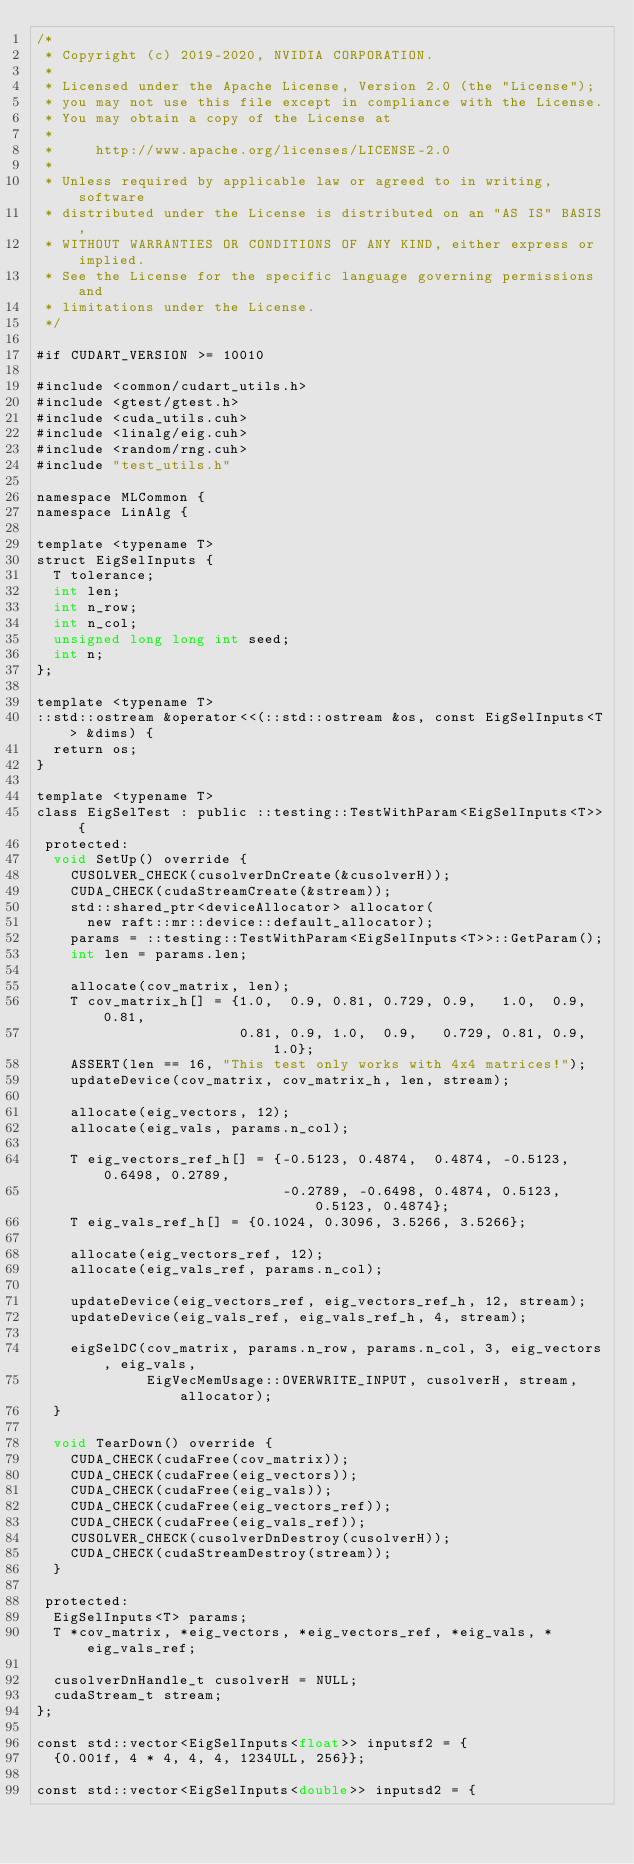<code> <loc_0><loc_0><loc_500><loc_500><_Cuda_>/*
 * Copyright (c) 2019-2020, NVIDIA CORPORATION.
 *
 * Licensed under the Apache License, Version 2.0 (the "License");
 * you may not use this file except in compliance with the License.
 * You may obtain a copy of the License at
 *
 *     http://www.apache.org/licenses/LICENSE-2.0
 *
 * Unless required by applicable law or agreed to in writing, software
 * distributed under the License is distributed on an "AS IS" BASIS,
 * WITHOUT WARRANTIES OR CONDITIONS OF ANY KIND, either express or implied.
 * See the License for the specific language governing permissions and
 * limitations under the License.
 */

#if CUDART_VERSION >= 10010

#include <common/cudart_utils.h>
#include <gtest/gtest.h>
#include <cuda_utils.cuh>
#include <linalg/eig.cuh>
#include <random/rng.cuh>
#include "test_utils.h"

namespace MLCommon {
namespace LinAlg {

template <typename T>
struct EigSelInputs {
  T tolerance;
  int len;
  int n_row;
  int n_col;
  unsigned long long int seed;
  int n;
};

template <typename T>
::std::ostream &operator<<(::std::ostream &os, const EigSelInputs<T> &dims) {
  return os;
}

template <typename T>
class EigSelTest : public ::testing::TestWithParam<EigSelInputs<T>> {
 protected:
  void SetUp() override {
    CUSOLVER_CHECK(cusolverDnCreate(&cusolverH));
    CUDA_CHECK(cudaStreamCreate(&stream));
    std::shared_ptr<deviceAllocator> allocator(
      new raft::mr::device::default_allocator);
    params = ::testing::TestWithParam<EigSelInputs<T>>::GetParam();
    int len = params.len;

    allocate(cov_matrix, len);
    T cov_matrix_h[] = {1.0,  0.9, 0.81, 0.729, 0.9,   1.0,  0.9, 0.81,
                        0.81, 0.9, 1.0,  0.9,   0.729, 0.81, 0.9, 1.0};
    ASSERT(len == 16, "This test only works with 4x4 matrices!");
    updateDevice(cov_matrix, cov_matrix_h, len, stream);

    allocate(eig_vectors, 12);
    allocate(eig_vals, params.n_col);

    T eig_vectors_ref_h[] = {-0.5123, 0.4874,  0.4874, -0.5123, 0.6498, 0.2789,
                             -0.2789, -0.6498, 0.4874, 0.5123,  0.5123, 0.4874};
    T eig_vals_ref_h[] = {0.1024, 0.3096, 3.5266, 3.5266};

    allocate(eig_vectors_ref, 12);
    allocate(eig_vals_ref, params.n_col);

    updateDevice(eig_vectors_ref, eig_vectors_ref_h, 12, stream);
    updateDevice(eig_vals_ref, eig_vals_ref_h, 4, stream);

    eigSelDC(cov_matrix, params.n_row, params.n_col, 3, eig_vectors, eig_vals,
             EigVecMemUsage::OVERWRITE_INPUT, cusolverH, stream, allocator);
  }

  void TearDown() override {
    CUDA_CHECK(cudaFree(cov_matrix));
    CUDA_CHECK(cudaFree(eig_vectors));
    CUDA_CHECK(cudaFree(eig_vals));
    CUDA_CHECK(cudaFree(eig_vectors_ref));
    CUDA_CHECK(cudaFree(eig_vals_ref));
    CUSOLVER_CHECK(cusolverDnDestroy(cusolverH));
    CUDA_CHECK(cudaStreamDestroy(stream));
  }

 protected:
  EigSelInputs<T> params;
  T *cov_matrix, *eig_vectors, *eig_vectors_ref, *eig_vals, *eig_vals_ref;

  cusolverDnHandle_t cusolverH = NULL;
  cudaStream_t stream;
};

const std::vector<EigSelInputs<float>> inputsf2 = {
  {0.001f, 4 * 4, 4, 4, 1234ULL, 256}};

const std::vector<EigSelInputs<double>> inputsd2 = {</code> 